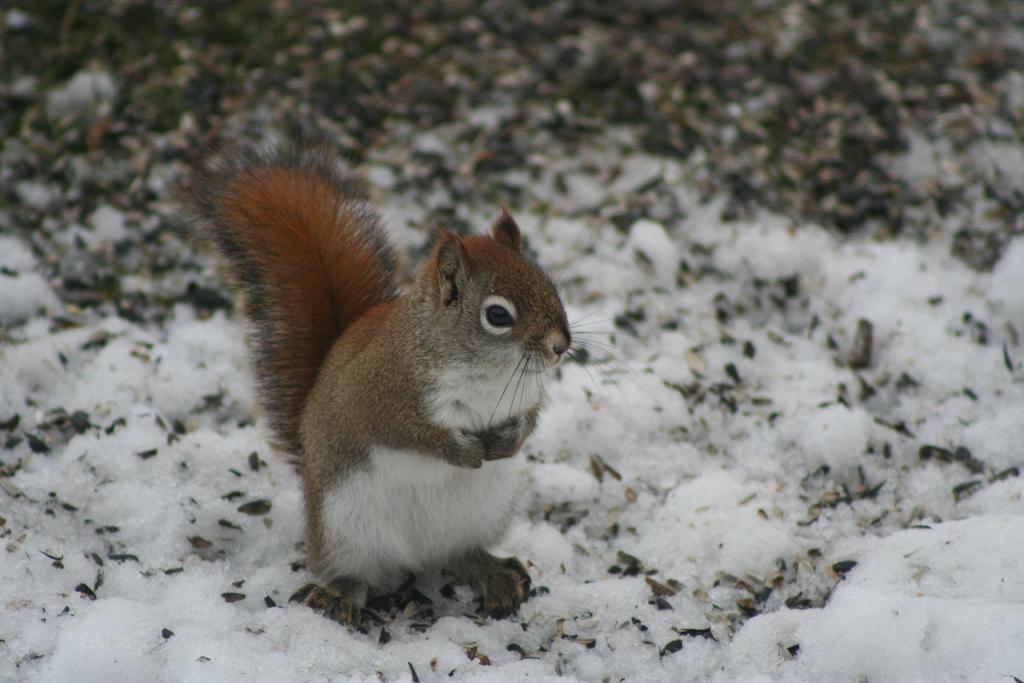Could you give a brief overview of what you see in this image? In this picture I can see a squirrel, there is snow, and there is blur background. 